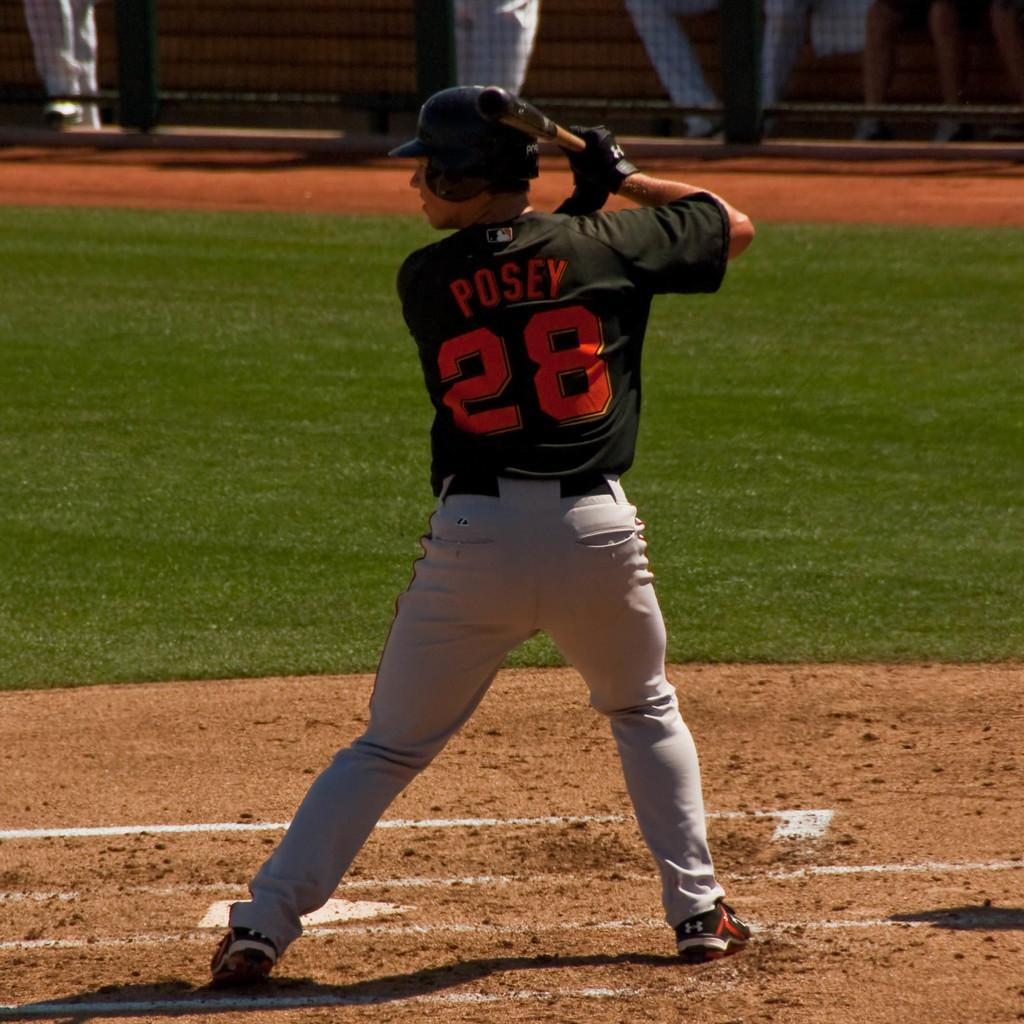<image>
Summarize the visual content of the image. Baseball player wearing a black jersey that says Posey. 